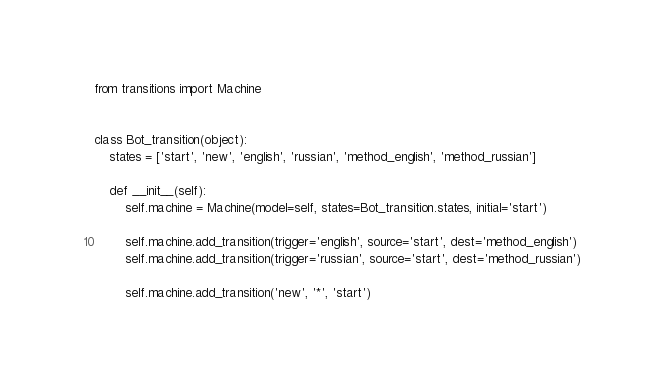<code> <loc_0><loc_0><loc_500><loc_500><_Python_>from transitions import Machine


class Bot_transition(object):
    states = ['start', 'new', 'english', 'russian', 'method_english', 'method_russian']

    def __init__(self):
        self.machine = Machine(model=self, states=Bot_transition.states, initial='start')

        self.machine.add_transition(trigger='english', source='start', dest='method_english')
        self.machine.add_transition(trigger='russian', source='start', dest='method_russian')

        self.machine.add_transition('new', '*', 'start')
</code> 